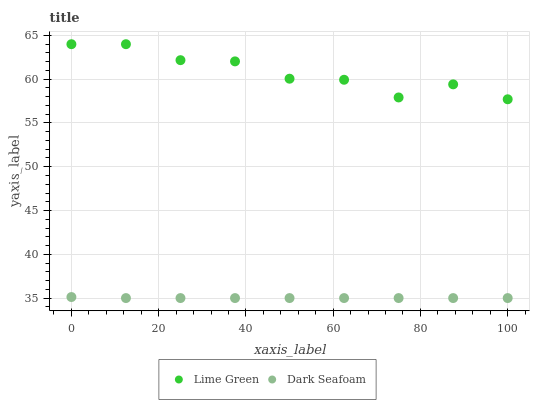Does Dark Seafoam have the minimum area under the curve?
Answer yes or no. Yes. Does Lime Green have the maximum area under the curve?
Answer yes or no. Yes. Does Lime Green have the minimum area under the curve?
Answer yes or no. No. Is Dark Seafoam the smoothest?
Answer yes or no. Yes. Is Lime Green the roughest?
Answer yes or no. Yes. Is Lime Green the smoothest?
Answer yes or no. No. Does Dark Seafoam have the lowest value?
Answer yes or no. Yes. Does Lime Green have the lowest value?
Answer yes or no. No. Does Lime Green have the highest value?
Answer yes or no. Yes. Is Dark Seafoam less than Lime Green?
Answer yes or no. Yes. Is Lime Green greater than Dark Seafoam?
Answer yes or no. Yes. Does Dark Seafoam intersect Lime Green?
Answer yes or no. No. 